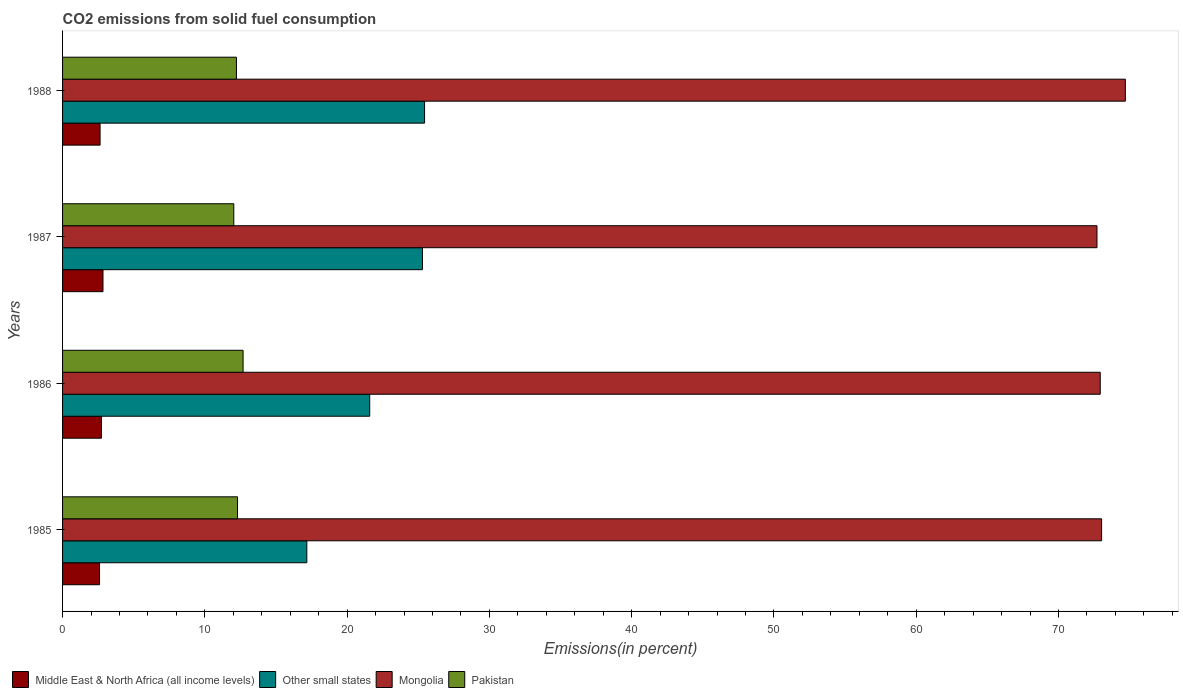How many different coloured bars are there?
Provide a succinct answer. 4. How many groups of bars are there?
Your answer should be compact. 4. Are the number of bars on each tick of the Y-axis equal?
Your answer should be very brief. Yes. How many bars are there on the 2nd tick from the top?
Ensure brevity in your answer.  4. In how many cases, is the number of bars for a given year not equal to the number of legend labels?
Your answer should be compact. 0. What is the total CO2 emitted in Mongolia in 1986?
Make the answer very short. 72.93. Across all years, what is the maximum total CO2 emitted in Pakistan?
Keep it short and to the point. 12.69. Across all years, what is the minimum total CO2 emitted in Pakistan?
Give a very brief answer. 12.04. What is the total total CO2 emitted in Other small states in the graph?
Offer a terse response. 89.5. What is the difference between the total CO2 emitted in Mongolia in 1986 and that in 1987?
Keep it short and to the point. 0.23. What is the difference between the total CO2 emitted in Mongolia in 1985 and the total CO2 emitted in Middle East & North Africa (all income levels) in 1986?
Keep it short and to the point. 70.3. What is the average total CO2 emitted in Mongolia per year?
Give a very brief answer. 73.34. In the year 1986, what is the difference between the total CO2 emitted in Mongolia and total CO2 emitted in Pakistan?
Your response must be concise. 60.25. In how many years, is the total CO2 emitted in Other small states greater than 66 %?
Your answer should be very brief. 0. What is the ratio of the total CO2 emitted in Pakistan in 1987 to that in 1988?
Make the answer very short. 0.98. Is the difference between the total CO2 emitted in Mongolia in 1987 and 1988 greater than the difference between the total CO2 emitted in Pakistan in 1987 and 1988?
Provide a short and direct response. No. What is the difference between the highest and the second highest total CO2 emitted in Pakistan?
Ensure brevity in your answer.  0.39. What is the difference between the highest and the lowest total CO2 emitted in Mongolia?
Offer a very short reply. 1.99. Is the sum of the total CO2 emitted in Other small states in 1986 and 1987 greater than the maximum total CO2 emitted in Middle East & North Africa (all income levels) across all years?
Offer a terse response. Yes. Is it the case that in every year, the sum of the total CO2 emitted in Other small states and total CO2 emitted in Pakistan is greater than the sum of total CO2 emitted in Mongolia and total CO2 emitted in Middle East & North Africa (all income levels)?
Offer a terse response. Yes. What does the 3rd bar from the top in 1986 represents?
Your answer should be very brief. Other small states. What does the 1st bar from the bottom in 1985 represents?
Provide a short and direct response. Middle East & North Africa (all income levels). How many years are there in the graph?
Keep it short and to the point. 4. What is the difference between two consecutive major ticks on the X-axis?
Offer a terse response. 10. Are the values on the major ticks of X-axis written in scientific E-notation?
Offer a very short reply. No. Does the graph contain any zero values?
Keep it short and to the point. No. What is the title of the graph?
Provide a short and direct response. CO2 emissions from solid fuel consumption. Does "Caribbean small states" appear as one of the legend labels in the graph?
Keep it short and to the point. No. What is the label or title of the X-axis?
Ensure brevity in your answer.  Emissions(in percent). What is the label or title of the Y-axis?
Offer a terse response. Years. What is the Emissions(in percent) of Middle East & North Africa (all income levels) in 1985?
Your response must be concise. 2.6. What is the Emissions(in percent) of Other small states in 1985?
Your response must be concise. 17.17. What is the Emissions(in percent) in Mongolia in 1985?
Ensure brevity in your answer.  73.03. What is the Emissions(in percent) of Pakistan in 1985?
Ensure brevity in your answer.  12.3. What is the Emissions(in percent) of Middle East & North Africa (all income levels) in 1986?
Your answer should be compact. 2.73. What is the Emissions(in percent) of Other small states in 1986?
Your answer should be compact. 21.59. What is the Emissions(in percent) in Mongolia in 1986?
Your answer should be very brief. 72.93. What is the Emissions(in percent) in Pakistan in 1986?
Your answer should be very brief. 12.69. What is the Emissions(in percent) in Middle East & North Africa (all income levels) in 1987?
Provide a short and direct response. 2.84. What is the Emissions(in percent) of Other small states in 1987?
Make the answer very short. 25.3. What is the Emissions(in percent) in Mongolia in 1987?
Ensure brevity in your answer.  72.71. What is the Emissions(in percent) in Pakistan in 1987?
Your answer should be very brief. 12.04. What is the Emissions(in percent) in Middle East & North Africa (all income levels) in 1988?
Keep it short and to the point. 2.64. What is the Emissions(in percent) in Other small states in 1988?
Provide a short and direct response. 25.44. What is the Emissions(in percent) in Mongolia in 1988?
Make the answer very short. 74.7. What is the Emissions(in percent) of Pakistan in 1988?
Provide a short and direct response. 12.22. Across all years, what is the maximum Emissions(in percent) in Middle East & North Africa (all income levels)?
Offer a very short reply. 2.84. Across all years, what is the maximum Emissions(in percent) in Other small states?
Make the answer very short. 25.44. Across all years, what is the maximum Emissions(in percent) in Mongolia?
Provide a short and direct response. 74.7. Across all years, what is the maximum Emissions(in percent) of Pakistan?
Give a very brief answer. 12.69. Across all years, what is the minimum Emissions(in percent) of Middle East & North Africa (all income levels)?
Ensure brevity in your answer.  2.6. Across all years, what is the minimum Emissions(in percent) of Other small states?
Your answer should be very brief. 17.17. Across all years, what is the minimum Emissions(in percent) of Mongolia?
Your answer should be compact. 72.71. Across all years, what is the minimum Emissions(in percent) in Pakistan?
Make the answer very short. 12.04. What is the total Emissions(in percent) of Middle East & North Africa (all income levels) in the graph?
Your answer should be very brief. 10.81. What is the total Emissions(in percent) of Other small states in the graph?
Your answer should be compact. 89.5. What is the total Emissions(in percent) of Mongolia in the graph?
Provide a short and direct response. 293.37. What is the total Emissions(in percent) of Pakistan in the graph?
Keep it short and to the point. 49.24. What is the difference between the Emissions(in percent) in Middle East & North Africa (all income levels) in 1985 and that in 1986?
Provide a succinct answer. -0.13. What is the difference between the Emissions(in percent) of Other small states in 1985 and that in 1986?
Provide a short and direct response. -4.42. What is the difference between the Emissions(in percent) in Mongolia in 1985 and that in 1986?
Your answer should be compact. 0.1. What is the difference between the Emissions(in percent) in Pakistan in 1985 and that in 1986?
Make the answer very short. -0.39. What is the difference between the Emissions(in percent) of Middle East & North Africa (all income levels) in 1985 and that in 1987?
Make the answer very short. -0.24. What is the difference between the Emissions(in percent) in Other small states in 1985 and that in 1987?
Your response must be concise. -8.13. What is the difference between the Emissions(in percent) of Mongolia in 1985 and that in 1987?
Your answer should be compact. 0.32. What is the difference between the Emissions(in percent) in Pakistan in 1985 and that in 1987?
Make the answer very short. 0.26. What is the difference between the Emissions(in percent) of Middle East & North Africa (all income levels) in 1985 and that in 1988?
Keep it short and to the point. -0.04. What is the difference between the Emissions(in percent) of Other small states in 1985 and that in 1988?
Your answer should be compact. -8.27. What is the difference between the Emissions(in percent) of Mongolia in 1985 and that in 1988?
Your answer should be compact. -1.67. What is the difference between the Emissions(in percent) in Pakistan in 1985 and that in 1988?
Give a very brief answer. 0.08. What is the difference between the Emissions(in percent) in Middle East & North Africa (all income levels) in 1986 and that in 1987?
Provide a succinct answer. -0.11. What is the difference between the Emissions(in percent) in Other small states in 1986 and that in 1987?
Offer a terse response. -3.71. What is the difference between the Emissions(in percent) of Mongolia in 1986 and that in 1987?
Keep it short and to the point. 0.23. What is the difference between the Emissions(in percent) of Pakistan in 1986 and that in 1987?
Provide a short and direct response. 0.65. What is the difference between the Emissions(in percent) in Middle East & North Africa (all income levels) in 1986 and that in 1988?
Your answer should be very brief. 0.1. What is the difference between the Emissions(in percent) in Other small states in 1986 and that in 1988?
Give a very brief answer. -3.85. What is the difference between the Emissions(in percent) of Mongolia in 1986 and that in 1988?
Make the answer very short. -1.77. What is the difference between the Emissions(in percent) of Pakistan in 1986 and that in 1988?
Keep it short and to the point. 0.47. What is the difference between the Emissions(in percent) of Middle East & North Africa (all income levels) in 1987 and that in 1988?
Your answer should be compact. 0.2. What is the difference between the Emissions(in percent) of Other small states in 1987 and that in 1988?
Provide a succinct answer. -0.15. What is the difference between the Emissions(in percent) in Mongolia in 1987 and that in 1988?
Your answer should be very brief. -1.99. What is the difference between the Emissions(in percent) in Pakistan in 1987 and that in 1988?
Your answer should be very brief. -0.19. What is the difference between the Emissions(in percent) of Middle East & North Africa (all income levels) in 1985 and the Emissions(in percent) of Other small states in 1986?
Make the answer very short. -18.99. What is the difference between the Emissions(in percent) of Middle East & North Africa (all income levels) in 1985 and the Emissions(in percent) of Mongolia in 1986?
Give a very brief answer. -70.34. What is the difference between the Emissions(in percent) of Middle East & North Africa (all income levels) in 1985 and the Emissions(in percent) of Pakistan in 1986?
Offer a very short reply. -10.09. What is the difference between the Emissions(in percent) of Other small states in 1985 and the Emissions(in percent) of Mongolia in 1986?
Make the answer very short. -55.77. What is the difference between the Emissions(in percent) of Other small states in 1985 and the Emissions(in percent) of Pakistan in 1986?
Provide a succinct answer. 4.48. What is the difference between the Emissions(in percent) in Mongolia in 1985 and the Emissions(in percent) in Pakistan in 1986?
Keep it short and to the point. 60.34. What is the difference between the Emissions(in percent) of Middle East & North Africa (all income levels) in 1985 and the Emissions(in percent) of Other small states in 1987?
Give a very brief answer. -22.7. What is the difference between the Emissions(in percent) of Middle East & North Africa (all income levels) in 1985 and the Emissions(in percent) of Mongolia in 1987?
Offer a terse response. -70.11. What is the difference between the Emissions(in percent) in Middle East & North Africa (all income levels) in 1985 and the Emissions(in percent) in Pakistan in 1987?
Offer a very short reply. -9.44. What is the difference between the Emissions(in percent) of Other small states in 1985 and the Emissions(in percent) of Mongolia in 1987?
Offer a terse response. -55.54. What is the difference between the Emissions(in percent) in Other small states in 1985 and the Emissions(in percent) in Pakistan in 1987?
Ensure brevity in your answer.  5.13. What is the difference between the Emissions(in percent) of Mongolia in 1985 and the Emissions(in percent) of Pakistan in 1987?
Your answer should be very brief. 60.99. What is the difference between the Emissions(in percent) in Middle East & North Africa (all income levels) in 1985 and the Emissions(in percent) in Other small states in 1988?
Make the answer very short. -22.84. What is the difference between the Emissions(in percent) of Middle East & North Africa (all income levels) in 1985 and the Emissions(in percent) of Mongolia in 1988?
Ensure brevity in your answer.  -72.1. What is the difference between the Emissions(in percent) of Middle East & North Africa (all income levels) in 1985 and the Emissions(in percent) of Pakistan in 1988?
Offer a very short reply. -9.62. What is the difference between the Emissions(in percent) of Other small states in 1985 and the Emissions(in percent) of Mongolia in 1988?
Provide a succinct answer. -57.53. What is the difference between the Emissions(in percent) of Other small states in 1985 and the Emissions(in percent) of Pakistan in 1988?
Provide a short and direct response. 4.95. What is the difference between the Emissions(in percent) in Mongolia in 1985 and the Emissions(in percent) in Pakistan in 1988?
Keep it short and to the point. 60.81. What is the difference between the Emissions(in percent) of Middle East & North Africa (all income levels) in 1986 and the Emissions(in percent) of Other small states in 1987?
Offer a terse response. -22.56. What is the difference between the Emissions(in percent) of Middle East & North Africa (all income levels) in 1986 and the Emissions(in percent) of Mongolia in 1987?
Make the answer very short. -69.97. What is the difference between the Emissions(in percent) in Middle East & North Africa (all income levels) in 1986 and the Emissions(in percent) in Pakistan in 1987?
Your response must be concise. -9.3. What is the difference between the Emissions(in percent) in Other small states in 1986 and the Emissions(in percent) in Mongolia in 1987?
Ensure brevity in your answer.  -51.12. What is the difference between the Emissions(in percent) of Other small states in 1986 and the Emissions(in percent) of Pakistan in 1987?
Ensure brevity in your answer.  9.55. What is the difference between the Emissions(in percent) in Mongolia in 1986 and the Emissions(in percent) in Pakistan in 1987?
Ensure brevity in your answer.  60.9. What is the difference between the Emissions(in percent) in Middle East & North Africa (all income levels) in 1986 and the Emissions(in percent) in Other small states in 1988?
Keep it short and to the point. -22.71. What is the difference between the Emissions(in percent) of Middle East & North Africa (all income levels) in 1986 and the Emissions(in percent) of Mongolia in 1988?
Your answer should be compact. -71.97. What is the difference between the Emissions(in percent) in Middle East & North Africa (all income levels) in 1986 and the Emissions(in percent) in Pakistan in 1988?
Your response must be concise. -9.49. What is the difference between the Emissions(in percent) in Other small states in 1986 and the Emissions(in percent) in Mongolia in 1988?
Keep it short and to the point. -53.11. What is the difference between the Emissions(in percent) of Other small states in 1986 and the Emissions(in percent) of Pakistan in 1988?
Make the answer very short. 9.37. What is the difference between the Emissions(in percent) of Mongolia in 1986 and the Emissions(in percent) of Pakistan in 1988?
Give a very brief answer. 60.71. What is the difference between the Emissions(in percent) of Middle East & North Africa (all income levels) in 1987 and the Emissions(in percent) of Other small states in 1988?
Keep it short and to the point. -22.6. What is the difference between the Emissions(in percent) of Middle East & North Africa (all income levels) in 1987 and the Emissions(in percent) of Mongolia in 1988?
Make the answer very short. -71.86. What is the difference between the Emissions(in percent) in Middle East & North Africa (all income levels) in 1987 and the Emissions(in percent) in Pakistan in 1988?
Ensure brevity in your answer.  -9.38. What is the difference between the Emissions(in percent) of Other small states in 1987 and the Emissions(in percent) of Mongolia in 1988?
Provide a short and direct response. -49.4. What is the difference between the Emissions(in percent) of Other small states in 1987 and the Emissions(in percent) of Pakistan in 1988?
Ensure brevity in your answer.  13.08. What is the difference between the Emissions(in percent) in Mongolia in 1987 and the Emissions(in percent) in Pakistan in 1988?
Offer a terse response. 60.48. What is the average Emissions(in percent) in Middle East & North Africa (all income levels) per year?
Give a very brief answer. 2.7. What is the average Emissions(in percent) in Other small states per year?
Keep it short and to the point. 22.37. What is the average Emissions(in percent) in Mongolia per year?
Offer a terse response. 73.34. What is the average Emissions(in percent) in Pakistan per year?
Your answer should be compact. 12.31. In the year 1985, what is the difference between the Emissions(in percent) of Middle East & North Africa (all income levels) and Emissions(in percent) of Other small states?
Make the answer very short. -14.57. In the year 1985, what is the difference between the Emissions(in percent) in Middle East & North Africa (all income levels) and Emissions(in percent) in Mongolia?
Offer a very short reply. -70.43. In the year 1985, what is the difference between the Emissions(in percent) in Middle East & North Africa (all income levels) and Emissions(in percent) in Pakistan?
Offer a terse response. -9.7. In the year 1985, what is the difference between the Emissions(in percent) in Other small states and Emissions(in percent) in Mongolia?
Provide a succinct answer. -55.86. In the year 1985, what is the difference between the Emissions(in percent) of Other small states and Emissions(in percent) of Pakistan?
Your response must be concise. 4.87. In the year 1985, what is the difference between the Emissions(in percent) of Mongolia and Emissions(in percent) of Pakistan?
Your answer should be very brief. 60.73. In the year 1986, what is the difference between the Emissions(in percent) in Middle East & North Africa (all income levels) and Emissions(in percent) in Other small states?
Ensure brevity in your answer.  -18.86. In the year 1986, what is the difference between the Emissions(in percent) in Middle East & North Africa (all income levels) and Emissions(in percent) in Mongolia?
Keep it short and to the point. -70.2. In the year 1986, what is the difference between the Emissions(in percent) in Middle East & North Africa (all income levels) and Emissions(in percent) in Pakistan?
Your answer should be very brief. -9.96. In the year 1986, what is the difference between the Emissions(in percent) in Other small states and Emissions(in percent) in Mongolia?
Offer a terse response. -51.34. In the year 1986, what is the difference between the Emissions(in percent) of Other small states and Emissions(in percent) of Pakistan?
Provide a short and direct response. 8.9. In the year 1986, what is the difference between the Emissions(in percent) in Mongolia and Emissions(in percent) in Pakistan?
Your answer should be compact. 60.25. In the year 1987, what is the difference between the Emissions(in percent) in Middle East & North Africa (all income levels) and Emissions(in percent) in Other small states?
Your response must be concise. -22.45. In the year 1987, what is the difference between the Emissions(in percent) of Middle East & North Africa (all income levels) and Emissions(in percent) of Mongolia?
Your response must be concise. -69.86. In the year 1987, what is the difference between the Emissions(in percent) in Middle East & North Africa (all income levels) and Emissions(in percent) in Pakistan?
Offer a very short reply. -9.19. In the year 1987, what is the difference between the Emissions(in percent) in Other small states and Emissions(in percent) in Mongolia?
Give a very brief answer. -47.41. In the year 1987, what is the difference between the Emissions(in percent) in Other small states and Emissions(in percent) in Pakistan?
Provide a succinct answer. 13.26. In the year 1987, what is the difference between the Emissions(in percent) in Mongolia and Emissions(in percent) in Pakistan?
Offer a terse response. 60.67. In the year 1988, what is the difference between the Emissions(in percent) of Middle East & North Africa (all income levels) and Emissions(in percent) of Other small states?
Offer a very short reply. -22.81. In the year 1988, what is the difference between the Emissions(in percent) of Middle East & North Africa (all income levels) and Emissions(in percent) of Mongolia?
Keep it short and to the point. -72.06. In the year 1988, what is the difference between the Emissions(in percent) of Middle East & North Africa (all income levels) and Emissions(in percent) of Pakistan?
Provide a succinct answer. -9.58. In the year 1988, what is the difference between the Emissions(in percent) of Other small states and Emissions(in percent) of Mongolia?
Your answer should be compact. -49.26. In the year 1988, what is the difference between the Emissions(in percent) of Other small states and Emissions(in percent) of Pakistan?
Your answer should be compact. 13.22. In the year 1988, what is the difference between the Emissions(in percent) in Mongolia and Emissions(in percent) in Pakistan?
Provide a succinct answer. 62.48. What is the ratio of the Emissions(in percent) in Middle East & North Africa (all income levels) in 1985 to that in 1986?
Offer a terse response. 0.95. What is the ratio of the Emissions(in percent) in Other small states in 1985 to that in 1986?
Give a very brief answer. 0.8. What is the ratio of the Emissions(in percent) in Pakistan in 1985 to that in 1986?
Make the answer very short. 0.97. What is the ratio of the Emissions(in percent) in Middle East & North Africa (all income levels) in 1985 to that in 1987?
Offer a terse response. 0.91. What is the ratio of the Emissions(in percent) in Other small states in 1985 to that in 1987?
Make the answer very short. 0.68. What is the ratio of the Emissions(in percent) of Mongolia in 1985 to that in 1987?
Give a very brief answer. 1. What is the ratio of the Emissions(in percent) in Pakistan in 1985 to that in 1987?
Offer a very short reply. 1.02. What is the ratio of the Emissions(in percent) in Middle East & North Africa (all income levels) in 1985 to that in 1988?
Your answer should be compact. 0.99. What is the ratio of the Emissions(in percent) of Other small states in 1985 to that in 1988?
Make the answer very short. 0.67. What is the ratio of the Emissions(in percent) of Mongolia in 1985 to that in 1988?
Keep it short and to the point. 0.98. What is the ratio of the Emissions(in percent) in Middle East & North Africa (all income levels) in 1986 to that in 1987?
Ensure brevity in your answer.  0.96. What is the ratio of the Emissions(in percent) in Other small states in 1986 to that in 1987?
Provide a short and direct response. 0.85. What is the ratio of the Emissions(in percent) in Pakistan in 1986 to that in 1987?
Your answer should be compact. 1.05. What is the ratio of the Emissions(in percent) in Middle East & North Africa (all income levels) in 1986 to that in 1988?
Offer a terse response. 1.04. What is the ratio of the Emissions(in percent) in Other small states in 1986 to that in 1988?
Your answer should be very brief. 0.85. What is the ratio of the Emissions(in percent) in Mongolia in 1986 to that in 1988?
Your answer should be compact. 0.98. What is the ratio of the Emissions(in percent) in Pakistan in 1986 to that in 1988?
Provide a short and direct response. 1.04. What is the ratio of the Emissions(in percent) of Middle East & North Africa (all income levels) in 1987 to that in 1988?
Ensure brevity in your answer.  1.08. What is the ratio of the Emissions(in percent) in Mongolia in 1987 to that in 1988?
Offer a terse response. 0.97. What is the ratio of the Emissions(in percent) in Pakistan in 1987 to that in 1988?
Offer a very short reply. 0.98. What is the difference between the highest and the second highest Emissions(in percent) of Middle East & North Africa (all income levels)?
Provide a succinct answer. 0.11. What is the difference between the highest and the second highest Emissions(in percent) in Other small states?
Provide a short and direct response. 0.15. What is the difference between the highest and the second highest Emissions(in percent) of Mongolia?
Your answer should be compact. 1.67. What is the difference between the highest and the second highest Emissions(in percent) of Pakistan?
Give a very brief answer. 0.39. What is the difference between the highest and the lowest Emissions(in percent) of Middle East & North Africa (all income levels)?
Provide a short and direct response. 0.24. What is the difference between the highest and the lowest Emissions(in percent) in Other small states?
Offer a terse response. 8.27. What is the difference between the highest and the lowest Emissions(in percent) in Mongolia?
Give a very brief answer. 1.99. What is the difference between the highest and the lowest Emissions(in percent) in Pakistan?
Make the answer very short. 0.65. 